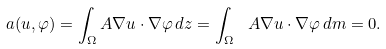<formula> <loc_0><loc_0><loc_500><loc_500>a ( u , \varphi ) = \int _ { \Omega } A \nabla u \cdot \nabla \varphi \, d z = \int _ { \Omega } \ A \nabla u \cdot \nabla \varphi \, d m = 0 .</formula> 